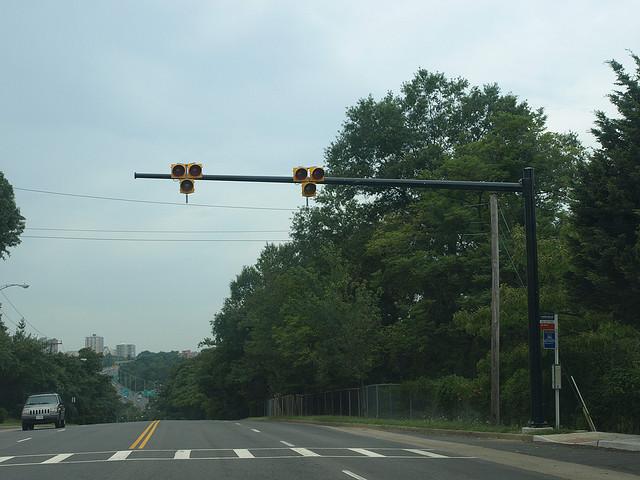How many cars are on the road?
Quick response, please. 1. Are the lights working?
Answer briefly. No. Is it autumn in this picture?
Answer briefly. No. How many traffic lights can you see?
Quick response, please. 2. What are ahead?
Keep it brief. Traffic lights. 